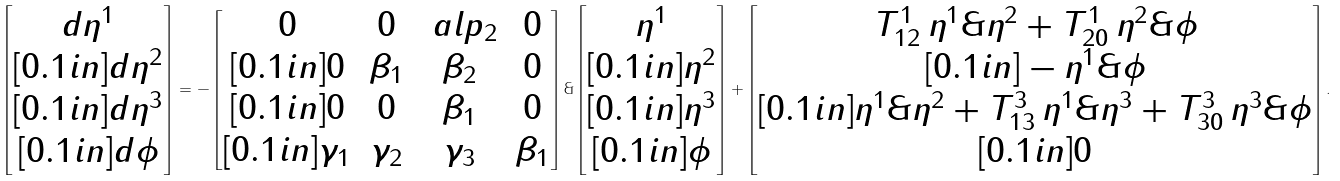Convert formula to latex. <formula><loc_0><loc_0><loc_500><loc_500>\begin{bmatrix} d \eta ^ { 1 } \\ [ 0 . 1 i n ] d \eta ^ { 2 } \\ [ 0 . 1 i n ] d \eta ^ { 3 } \\ [ 0 . 1 i n ] d \phi \end{bmatrix} = - \begin{bmatrix} 0 & 0 & \ a l p _ { 2 } & 0 \\ [ 0 . 1 i n ] 0 & \beta _ { 1 } & \beta _ { 2 } & 0 \\ [ 0 . 1 i n ] 0 & 0 & \beta _ { 1 } & 0 \\ [ 0 . 1 i n ] \gamma _ { 1 } & \gamma _ { 2 } & \gamma _ { 3 } & \beta _ { 1 } \end{bmatrix} \& \begin{bmatrix} \eta ^ { 1 } \\ [ 0 . 1 i n ] \eta ^ { 2 } \\ [ 0 . 1 i n ] \eta ^ { 3 } \\ [ 0 . 1 i n ] \phi \end{bmatrix} + \begin{bmatrix} T ^ { 1 } _ { 1 2 } \, \eta ^ { 1 } \& \eta ^ { 2 } + T ^ { 1 } _ { 2 0 } \, \eta ^ { 2 } \& \phi \\ [ 0 . 1 i n ] - \eta ^ { 1 } \& \phi \\ [ 0 . 1 i n ] \eta ^ { 1 } \& \eta ^ { 2 } + T ^ { 3 } _ { 1 3 } \, \eta ^ { 1 } \& \eta ^ { 3 } + T ^ { 3 } _ { 3 0 } \, \eta ^ { 3 } \& \phi \\ [ 0 . 1 i n ] 0 \end{bmatrix} .</formula> 